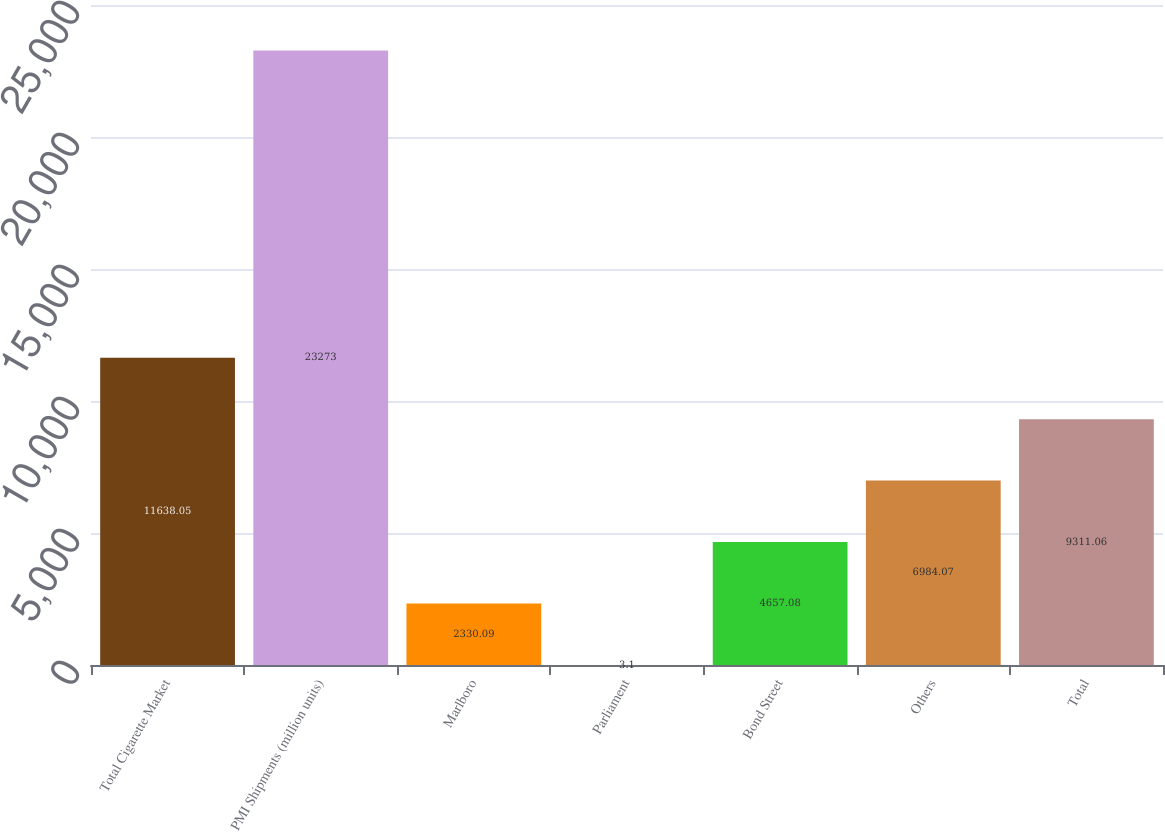Convert chart to OTSL. <chart><loc_0><loc_0><loc_500><loc_500><bar_chart><fcel>Total Cigarette Market<fcel>PMI Shipments (million units)<fcel>Marlboro<fcel>Parliament<fcel>Bond Street<fcel>Others<fcel>Total<nl><fcel>11638<fcel>23273<fcel>2330.09<fcel>3.1<fcel>4657.08<fcel>6984.07<fcel>9311.06<nl></chart> 